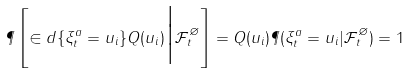<formula> <loc_0><loc_0><loc_500><loc_500>\P \left [ \in d \{ \xi ^ { a } _ { t } = u _ { i } \} Q ( u _ { i } ) \Big | \mathcal { F } ^ { \varnothing } _ { t } \right ] = Q ( u _ { i } ) \P ( \xi ^ { a } _ { t } = u _ { i } | \mathcal { F } ^ { \varnothing } _ { t } ) = 1</formula> 